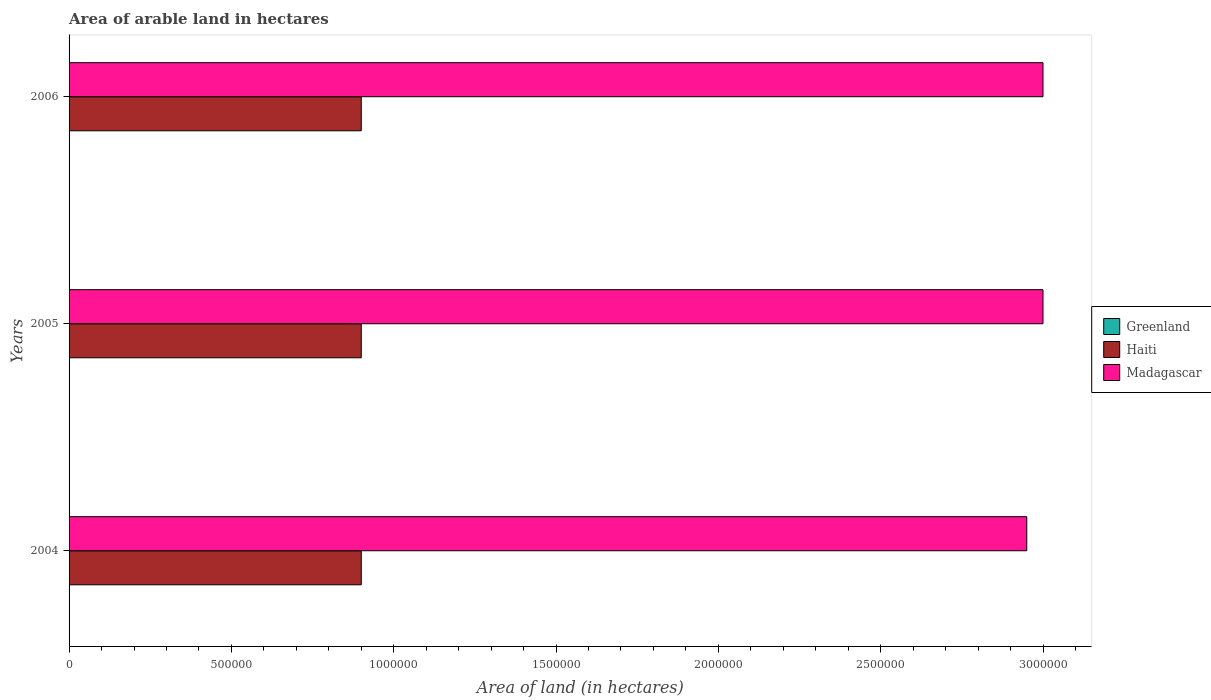How many different coloured bars are there?
Offer a very short reply. 3. How many groups of bars are there?
Provide a succinct answer. 3. Are the number of bars per tick equal to the number of legend labels?
Make the answer very short. Yes. Are the number of bars on each tick of the Y-axis equal?
Offer a terse response. Yes. How many bars are there on the 3rd tick from the bottom?
Offer a terse response. 3. What is the label of the 3rd group of bars from the top?
Give a very brief answer. 2004. What is the total arable land in Greenland in 2006?
Make the answer very short. 900. Across all years, what is the maximum total arable land in Madagascar?
Make the answer very short. 3.00e+06. Across all years, what is the minimum total arable land in Madagascar?
Provide a succinct answer. 2.95e+06. In which year was the total arable land in Haiti maximum?
Give a very brief answer. 2004. In which year was the total arable land in Madagascar minimum?
Keep it short and to the point. 2004. What is the total total arable land in Greenland in the graph?
Keep it short and to the point. 2700. What is the difference between the total arable land in Haiti in 2004 and that in 2006?
Your response must be concise. 0. What is the difference between the total arable land in Haiti in 2006 and the total arable land in Greenland in 2005?
Offer a very short reply. 8.99e+05. What is the average total arable land in Madagascar per year?
Provide a short and direct response. 2.98e+06. In the year 2005, what is the difference between the total arable land in Haiti and total arable land in Greenland?
Ensure brevity in your answer.  8.99e+05. What is the ratio of the total arable land in Madagascar in 2004 to that in 2006?
Give a very brief answer. 0.98. Is the total arable land in Haiti in 2004 less than that in 2005?
Your answer should be very brief. No. Is the difference between the total arable land in Haiti in 2004 and 2006 greater than the difference between the total arable land in Greenland in 2004 and 2006?
Make the answer very short. No. What is the difference between the highest and the lowest total arable land in Madagascar?
Offer a very short reply. 5.00e+04. Is the sum of the total arable land in Haiti in 2005 and 2006 greater than the maximum total arable land in Madagascar across all years?
Give a very brief answer. No. What does the 2nd bar from the top in 2004 represents?
Offer a terse response. Haiti. What does the 2nd bar from the bottom in 2005 represents?
Give a very brief answer. Haiti. How many bars are there?
Give a very brief answer. 9. Are all the bars in the graph horizontal?
Your answer should be very brief. Yes. Are the values on the major ticks of X-axis written in scientific E-notation?
Your response must be concise. No. Does the graph contain any zero values?
Your answer should be very brief. No. Does the graph contain grids?
Your answer should be compact. No. How many legend labels are there?
Provide a succinct answer. 3. What is the title of the graph?
Offer a very short reply. Area of arable land in hectares. Does "Middle income" appear as one of the legend labels in the graph?
Ensure brevity in your answer.  No. What is the label or title of the X-axis?
Give a very brief answer. Area of land (in hectares). What is the Area of land (in hectares) in Greenland in 2004?
Offer a terse response. 900. What is the Area of land (in hectares) in Haiti in 2004?
Your answer should be very brief. 9.00e+05. What is the Area of land (in hectares) in Madagascar in 2004?
Give a very brief answer. 2.95e+06. What is the Area of land (in hectares) in Greenland in 2005?
Your answer should be compact. 900. What is the Area of land (in hectares) of Madagascar in 2005?
Give a very brief answer. 3.00e+06. What is the Area of land (in hectares) of Greenland in 2006?
Ensure brevity in your answer.  900. What is the Area of land (in hectares) of Haiti in 2006?
Provide a succinct answer. 9.00e+05. Across all years, what is the maximum Area of land (in hectares) of Greenland?
Provide a short and direct response. 900. Across all years, what is the minimum Area of land (in hectares) of Greenland?
Offer a very short reply. 900. Across all years, what is the minimum Area of land (in hectares) in Madagascar?
Give a very brief answer. 2.95e+06. What is the total Area of land (in hectares) in Greenland in the graph?
Your answer should be very brief. 2700. What is the total Area of land (in hectares) in Haiti in the graph?
Provide a succinct answer. 2.70e+06. What is the total Area of land (in hectares) of Madagascar in the graph?
Provide a succinct answer. 8.95e+06. What is the difference between the Area of land (in hectares) of Greenland in 2004 and that in 2005?
Your answer should be very brief. 0. What is the difference between the Area of land (in hectares) in Haiti in 2004 and that in 2005?
Offer a terse response. 0. What is the difference between the Area of land (in hectares) in Madagascar in 2004 and that in 2005?
Provide a succinct answer. -5.00e+04. What is the difference between the Area of land (in hectares) in Haiti in 2004 and that in 2006?
Provide a succinct answer. 0. What is the difference between the Area of land (in hectares) of Greenland in 2005 and that in 2006?
Offer a very short reply. 0. What is the difference between the Area of land (in hectares) in Haiti in 2005 and that in 2006?
Give a very brief answer. 0. What is the difference between the Area of land (in hectares) of Greenland in 2004 and the Area of land (in hectares) of Haiti in 2005?
Ensure brevity in your answer.  -8.99e+05. What is the difference between the Area of land (in hectares) in Greenland in 2004 and the Area of land (in hectares) in Madagascar in 2005?
Keep it short and to the point. -3.00e+06. What is the difference between the Area of land (in hectares) of Haiti in 2004 and the Area of land (in hectares) of Madagascar in 2005?
Provide a succinct answer. -2.10e+06. What is the difference between the Area of land (in hectares) in Greenland in 2004 and the Area of land (in hectares) in Haiti in 2006?
Keep it short and to the point. -8.99e+05. What is the difference between the Area of land (in hectares) in Greenland in 2004 and the Area of land (in hectares) in Madagascar in 2006?
Offer a very short reply. -3.00e+06. What is the difference between the Area of land (in hectares) in Haiti in 2004 and the Area of land (in hectares) in Madagascar in 2006?
Your answer should be compact. -2.10e+06. What is the difference between the Area of land (in hectares) in Greenland in 2005 and the Area of land (in hectares) in Haiti in 2006?
Your response must be concise. -8.99e+05. What is the difference between the Area of land (in hectares) of Greenland in 2005 and the Area of land (in hectares) of Madagascar in 2006?
Your answer should be compact. -3.00e+06. What is the difference between the Area of land (in hectares) of Haiti in 2005 and the Area of land (in hectares) of Madagascar in 2006?
Give a very brief answer. -2.10e+06. What is the average Area of land (in hectares) of Greenland per year?
Your answer should be very brief. 900. What is the average Area of land (in hectares) in Madagascar per year?
Provide a short and direct response. 2.98e+06. In the year 2004, what is the difference between the Area of land (in hectares) in Greenland and Area of land (in hectares) in Haiti?
Your response must be concise. -8.99e+05. In the year 2004, what is the difference between the Area of land (in hectares) of Greenland and Area of land (in hectares) of Madagascar?
Offer a very short reply. -2.95e+06. In the year 2004, what is the difference between the Area of land (in hectares) in Haiti and Area of land (in hectares) in Madagascar?
Keep it short and to the point. -2.05e+06. In the year 2005, what is the difference between the Area of land (in hectares) in Greenland and Area of land (in hectares) in Haiti?
Make the answer very short. -8.99e+05. In the year 2005, what is the difference between the Area of land (in hectares) of Greenland and Area of land (in hectares) of Madagascar?
Provide a short and direct response. -3.00e+06. In the year 2005, what is the difference between the Area of land (in hectares) in Haiti and Area of land (in hectares) in Madagascar?
Your response must be concise. -2.10e+06. In the year 2006, what is the difference between the Area of land (in hectares) in Greenland and Area of land (in hectares) in Haiti?
Offer a very short reply. -8.99e+05. In the year 2006, what is the difference between the Area of land (in hectares) of Greenland and Area of land (in hectares) of Madagascar?
Provide a short and direct response. -3.00e+06. In the year 2006, what is the difference between the Area of land (in hectares) in Haiti and Area of land (in hectares) in Madagascar?
Provide a succinct answer. -2.10e+06. What is the ratio of the Area of land (in hectares) of Greenland in 2004 to that in 2005?
Give a very brief answer. 1. What is the ratio of the Area of land (in hectares) in Haiti in 2004 to that in 2005?
Offer a terse response. 1. What is the ratio of the Area of land (in hectares) in Madagascar in 2004 to that in 2005?
Keep it short and to the point. 0.98. What is the ratio of the Area of land (in hectares) in Madagascar in 2004 to that in 2006?
Offer a very short reply. 0.98. What is the ratio of the Area of land (in hectares) in Haiti in 2005 to that in 2006?
Offer a very short reply. 1. What is the ratio of the Area of land (in hectares) in Madagascar in 2005 to that in 2006?
Provide a short and direct response. 1. What is the difference between the highest and the second highest Area of land (in hectares) of Greenland?
Keep it short and to the point. 0. What is the difference between the highest and the lowest Area of land (in hectares) of Greenland?
Your response must be concise. 0. What is the difference between the highest and the lowest Area of land (in hectares) in Haiti?
Offer a terse response. 0. What is the difference between the highest and the lowest Area of land (in hectares) in Madagascar?
Your answer should be compact. 5.00e+04. 